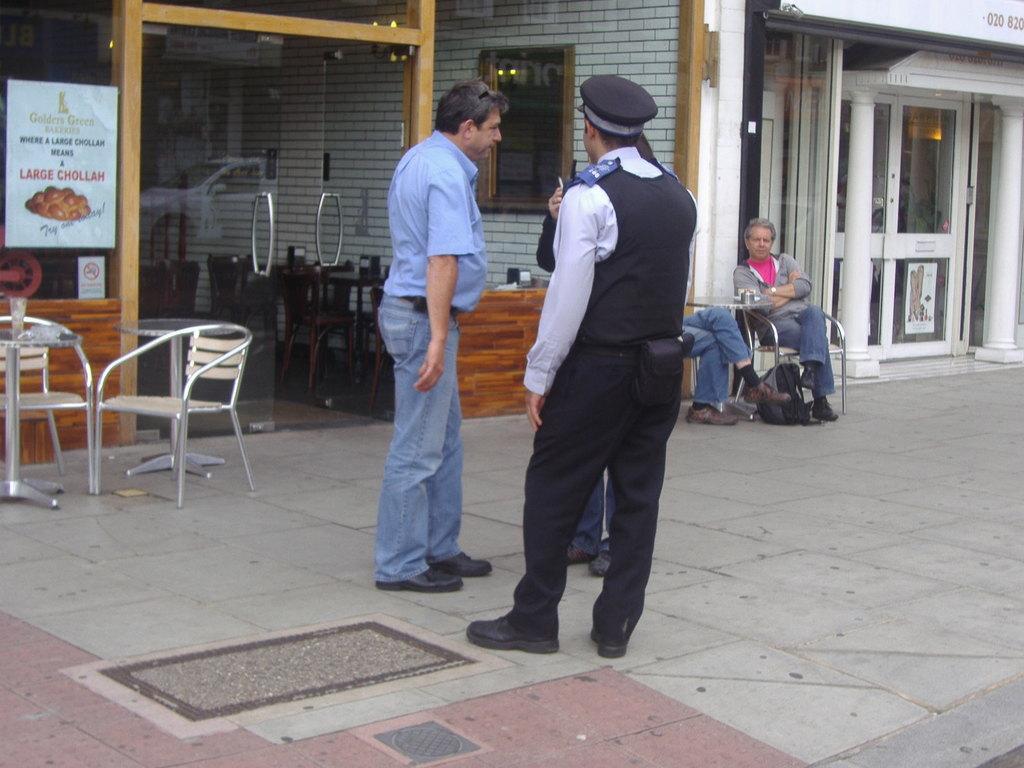Can you describe this image briefly? Three persons are standing at here. These are the chairs this is a glass door. 